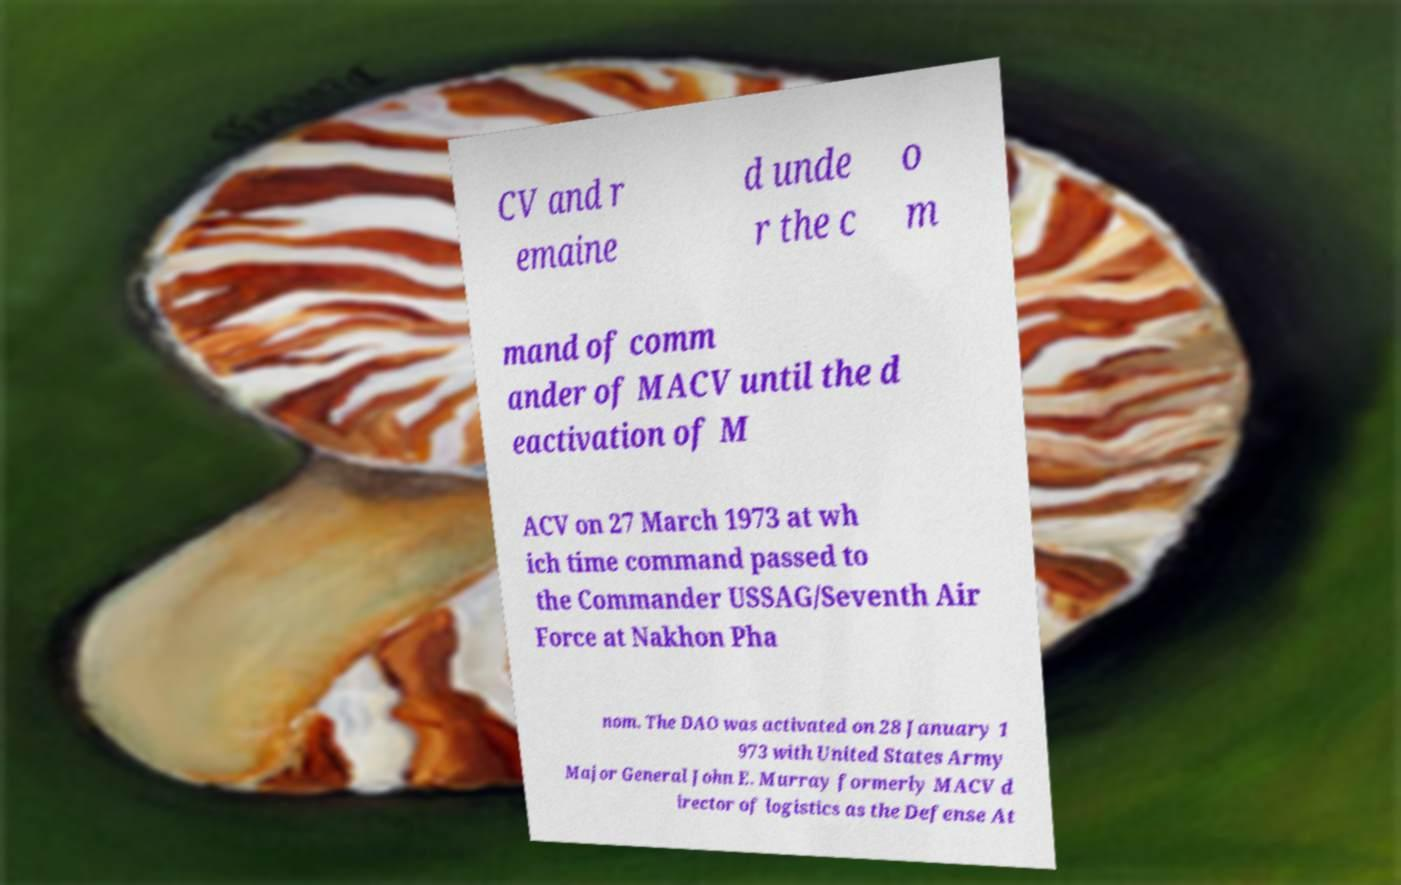Can you accurately transcribe the text from the provided image for me? CV and r emaine d unde r the c o m mand of comm ander of MACV until the d eactivation of M ACV on 27 March 1973 at wh ich time command passed to the Commander USSAG/Seventh Air Force at Nakhon Pha nom. The DAO was activated on 28 January 1 973 with United States Army Major General John E. Murray formerly MACV d irector of logistics as the Defense At 